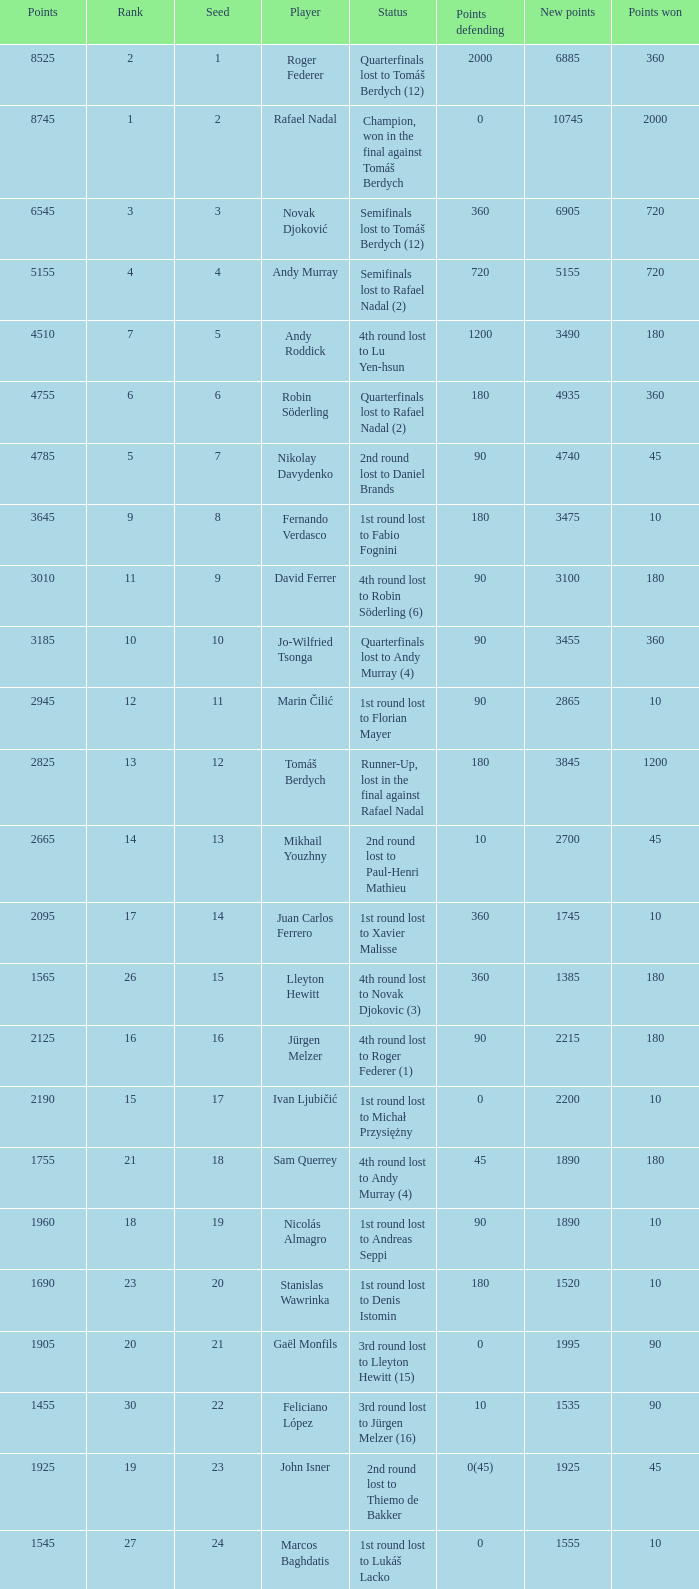Name the least new points for points defending is 1200 3490.0. 